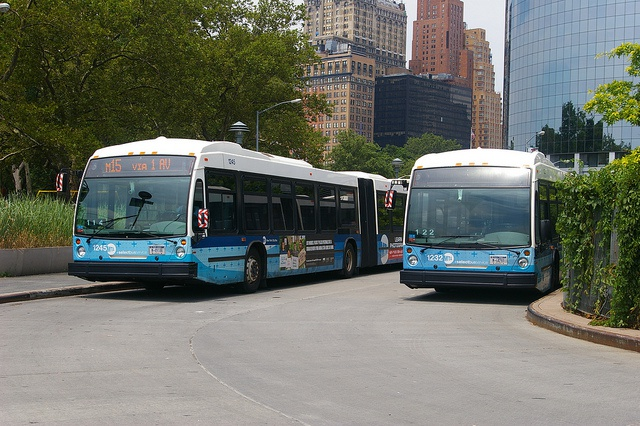Describe the objects in this image and their specific colors. I can see bus in darkgreen, black, gray, darkgray, and blue tones and bus in darkgreen, black, gray, white, and darkgray tones in this image. 